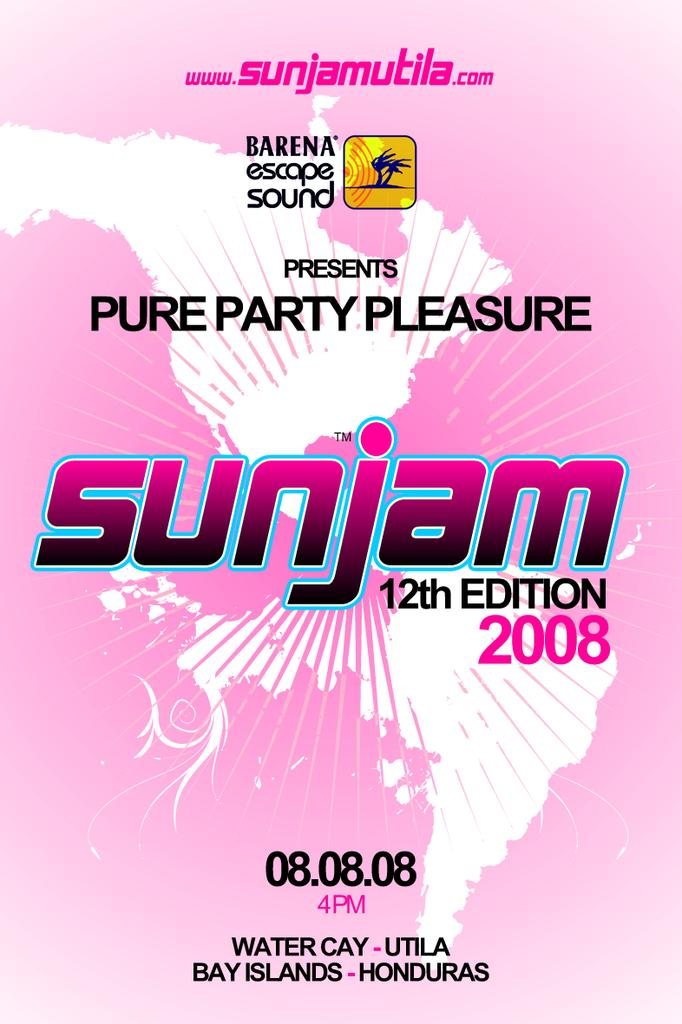Provide a one-sentence caption for the provided image. a poster that has the word sunjam on it. 